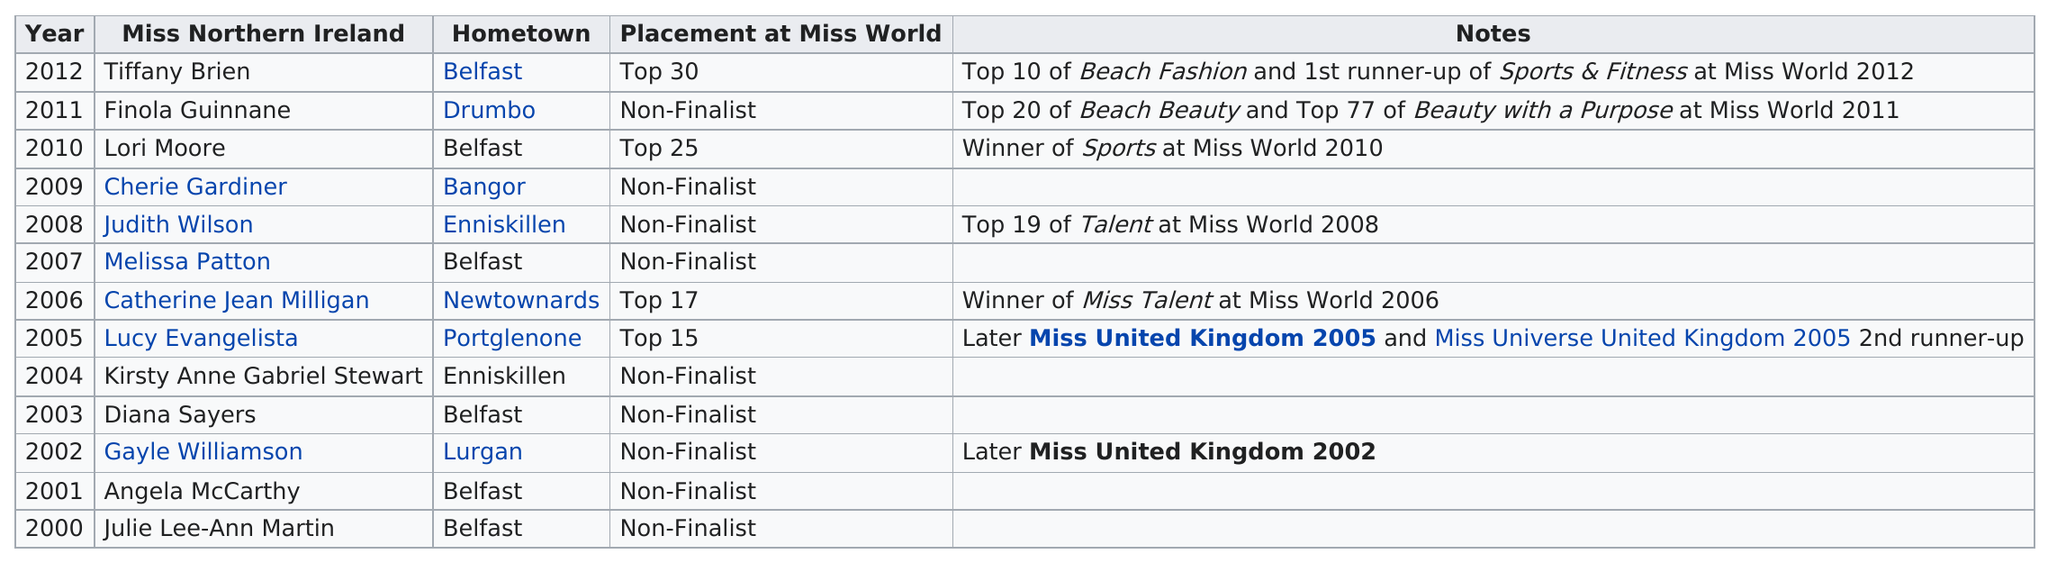Highlight a few significant elements in this photo. Lucy Evangelista was the only titleholder who reached the top 15 at Miss World. There were a total of 6 titleholders from Belfast. It is not clear from the provided text whether Catherine Jean Milligan or Lori Moore received a higher placement in Miss World. There have been a total of six Miss Northern Ireland winners from Belfast. Belfast, in Ireland, has the highest number of Miss Northern Ireland winners since 2000. 